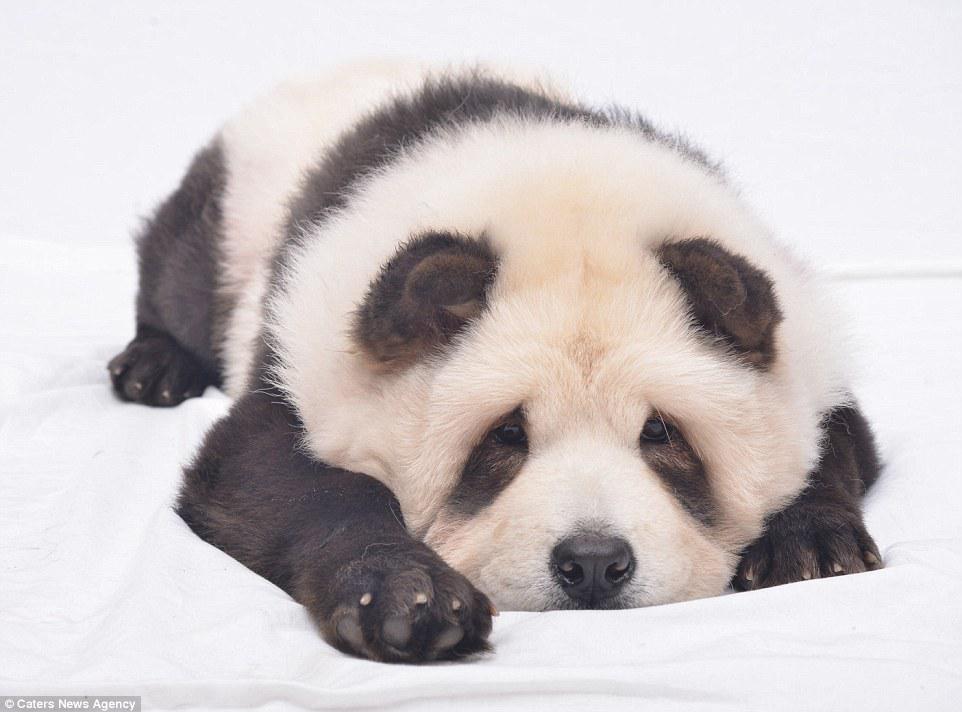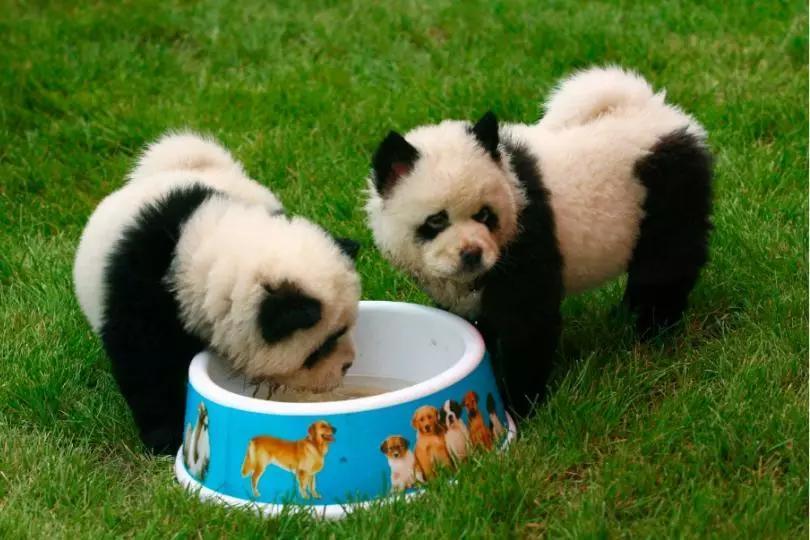The first image is the image on the left, the second image is the image on the right. Analyze the images presented: Is the assertion "A woman is hugging dogs dyes to look like pandas" valid? Answer yes or no. No. The first image is the image on the left, the second image is the image on the right. Assess this claim about the two images: "In one image, a woman poses with three dogs". Correct or not? Answer yes or no. No. 